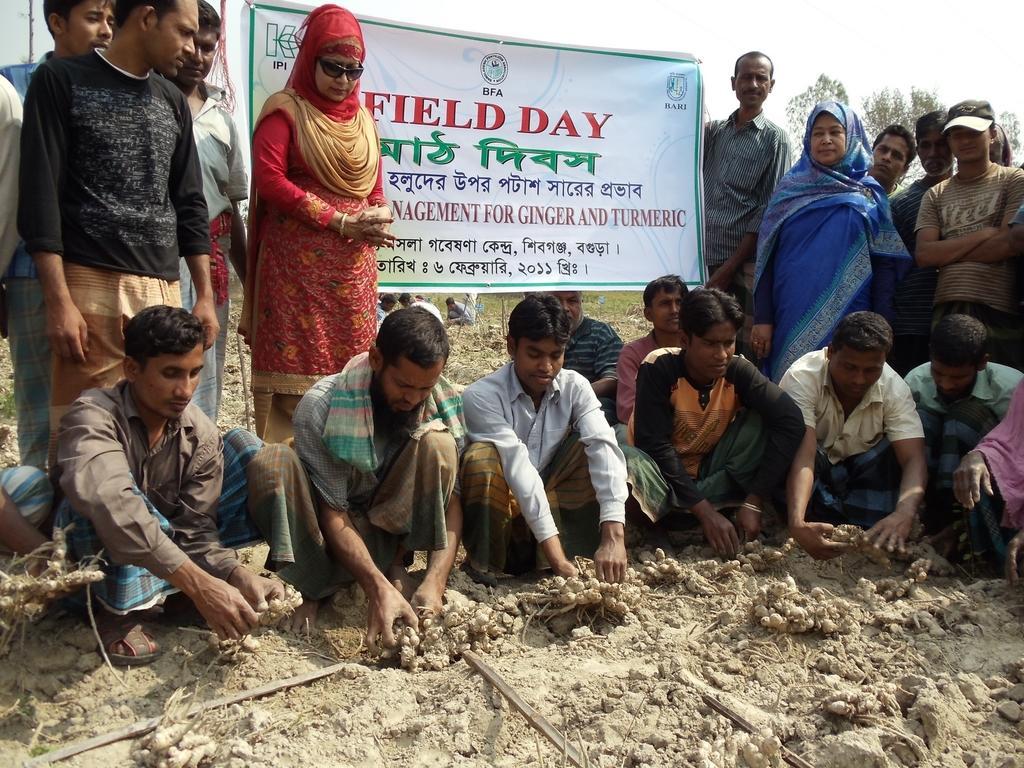Can you describe this image briefly? In this image we can see some people and among them few people are standing and few people are sitting on the ground and holding some objects and the place looks like a field. There is a banner with some text and we can see some trees in the background and at the top we can see the sky. 